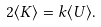<formula> <loc_0><loc_0><loc_500><loc_500>2 \langle K \rangle = k \langle U \rangle .</formula> 